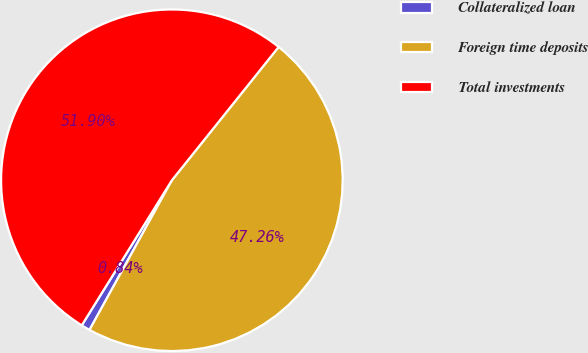Convert chart. <chart><loc_0><loc_0><loc_500><loc_500><pie_chart><fcel>Collateralized loan<fcel>Foreign time deposits<fcel>Total investments<nl><fcel>0.84%<fcel>47.26%<fcel>51.9%<nl></chart> 